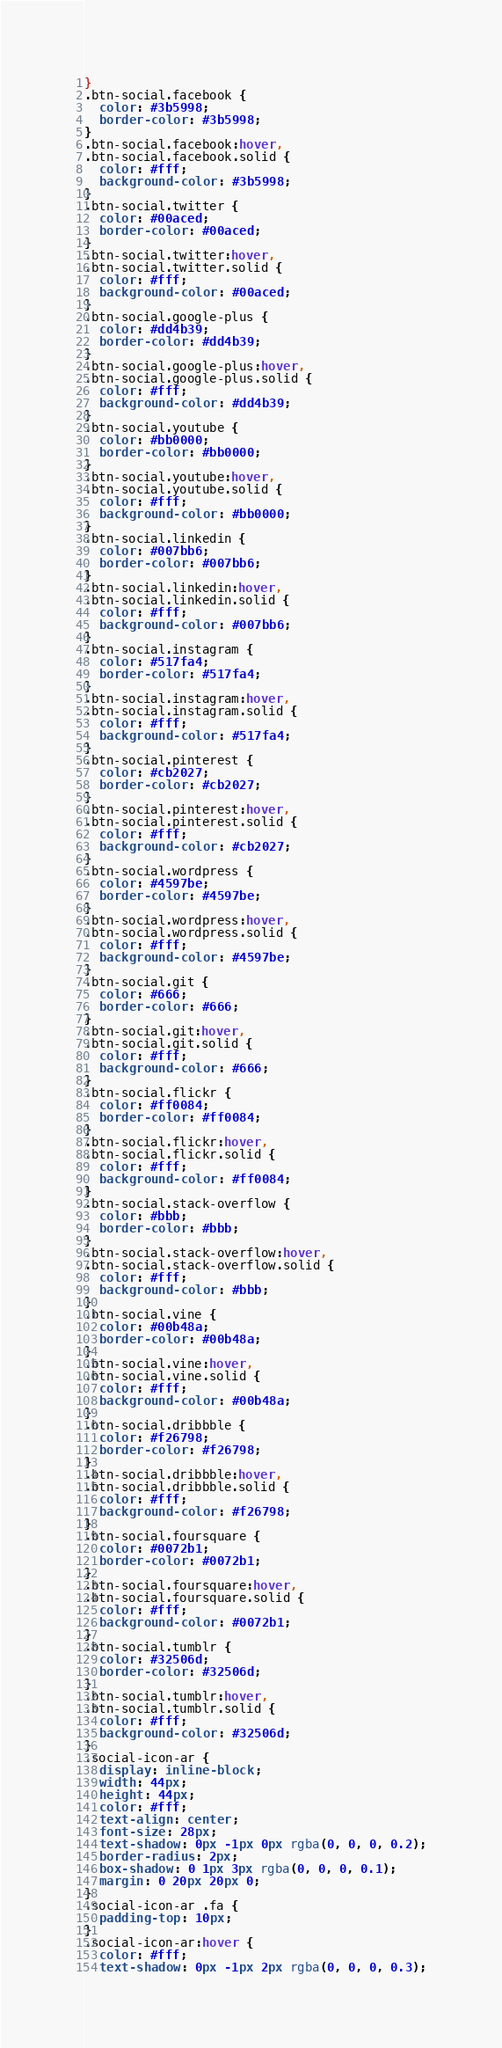Convert code to text. <code><loc_0><loc_0><loc_500><loc_500><_CSS_>}
.btn-social.facebook {
  color: #3b5998;
  border-color: #3b5998;
}
.btn-social.facebook:hover,
.btn-social.facebook.solid {
  color: #fff;
  background-color: #3b5998;
}
.btn-social.twitter {
  color: #00aced;
  border-color: #00aced;
}
.btn-social.twitter:hover,
.btn-social.twitter.solid {
  color: #fff;
  background-color: #00aced;
}
.btn-social.google-plus {
  color: #dd4b39;
  border-color: #dd4b39;
}
.btn-social.google-plus:hover,
.btn-social.google-plus.solid {
  color: #fff;
  background-color: #dd4b39;
}
.btn-social.youtube {
  color: #bb0000;
  border-color: #bb0000;
}
.btn-social.youtube:hover,
.btn-social.youtube.solid {
  color: #fff;
  background-color: #bb0000;
}
.btn-social.linkedin {
  color: #007bb6;
  border-color: #007bb6;
}
.btn-social.linkedin:hover,
.btn-social.linkedin.solid {
  color: #fff;
  background-color: #007bb6;
}
.btn-social.instagram {
  color: #517fa4;
  border-color: #517fa4;
}
.btn-social.instagram:hover,
.btn-social.instagram.solid {
  color: #fff;
  background-color: #517fa4;
}
.btn-social.pinterest {
  color: #cb2027;
  border-color: #cb2027;
}
.btn-social.pinterest:hover,
.btn-social.pinterest.solid {
  color: #fff;
  background-color: #cb2027;
}
.btn-social.wordpress {
  color: #4597be;
  border-color: #4597be;
}
.btn-social.wordpress:hover,
.btn-social.wordpress.solid {
  color: #fff;
  background-color: #4597be;
}
.btn-social.git {
  color: #666;
  border-color: #666;
}
.btn-social.git:hover,
.btn-social.git.solid {
  color: #fff;
  background-color: #666;
}
.btn-social.flickr {
  color: #ff0084;
  border-color: #ff0084;
}
.btn-social.flickr:hover,
.btn-social.flickr.solid {
  color: #fff;
  background-color: #ff0084;
}
.btn-social.stack-overflow {
  color: #bbb;
  border-color: #bbb;
}
.btn-social.stack-overflow:hover,
.btn-social.stack-overflow.solid {
  color: #fff;
  background-color: #bbb;
}
.btn-social.vine {
  color: #00b48a;
  border-color: #00b48a;
}
.btn-social.vine:hover,
.btn-social.vine.solid {
  color: #fff;
  background-color: #00b48a;
}
.btn-social.dribbble {
  color: #f26798;
  border-color: #f26798;
}
.btn-social.dribbble:hover,
.btn-social.dribbble.solid {
  color: #fff;
  background-color: #f26798;
}
.btn-social.foursquare {
  color: #0072b1;
  border-color: #0072b1;
}
.btn-social.foursquare:hover,
.btn-social.foursquare.solid {
  color: #fff;
  background-color: #0072b1;
}
.btn-social.tumblr {
  color: #32506d;
  border-color: #32506d;
}
.btn-social.tumblr:hover,
.btn-social.tumblr.solid {
  color: #fff;
  background-color: #32506d;
}
.social-icon-ar {
  display: inline-block;
  width: 44px;
  height: 44px;
  color: #fff;
  text-align: center;
  font-size: 28px;
  text-shadow: 0px -1px 0px rgba(0, 0, 0, 0.2);
  border-radius: 2px;
  box-shadow: 0 1px 3px rgba(0, 0, 0, 0.1);
  margin: 0 20px 20px 0;
}
.social-icon-ar .fa {
  padding-top: 10px;
}
.social-icon-ar:hover {
  color: #fff;
  text-shadow: 0px -1px 2px rgba(0, 0, 0, 0.3);</code> 